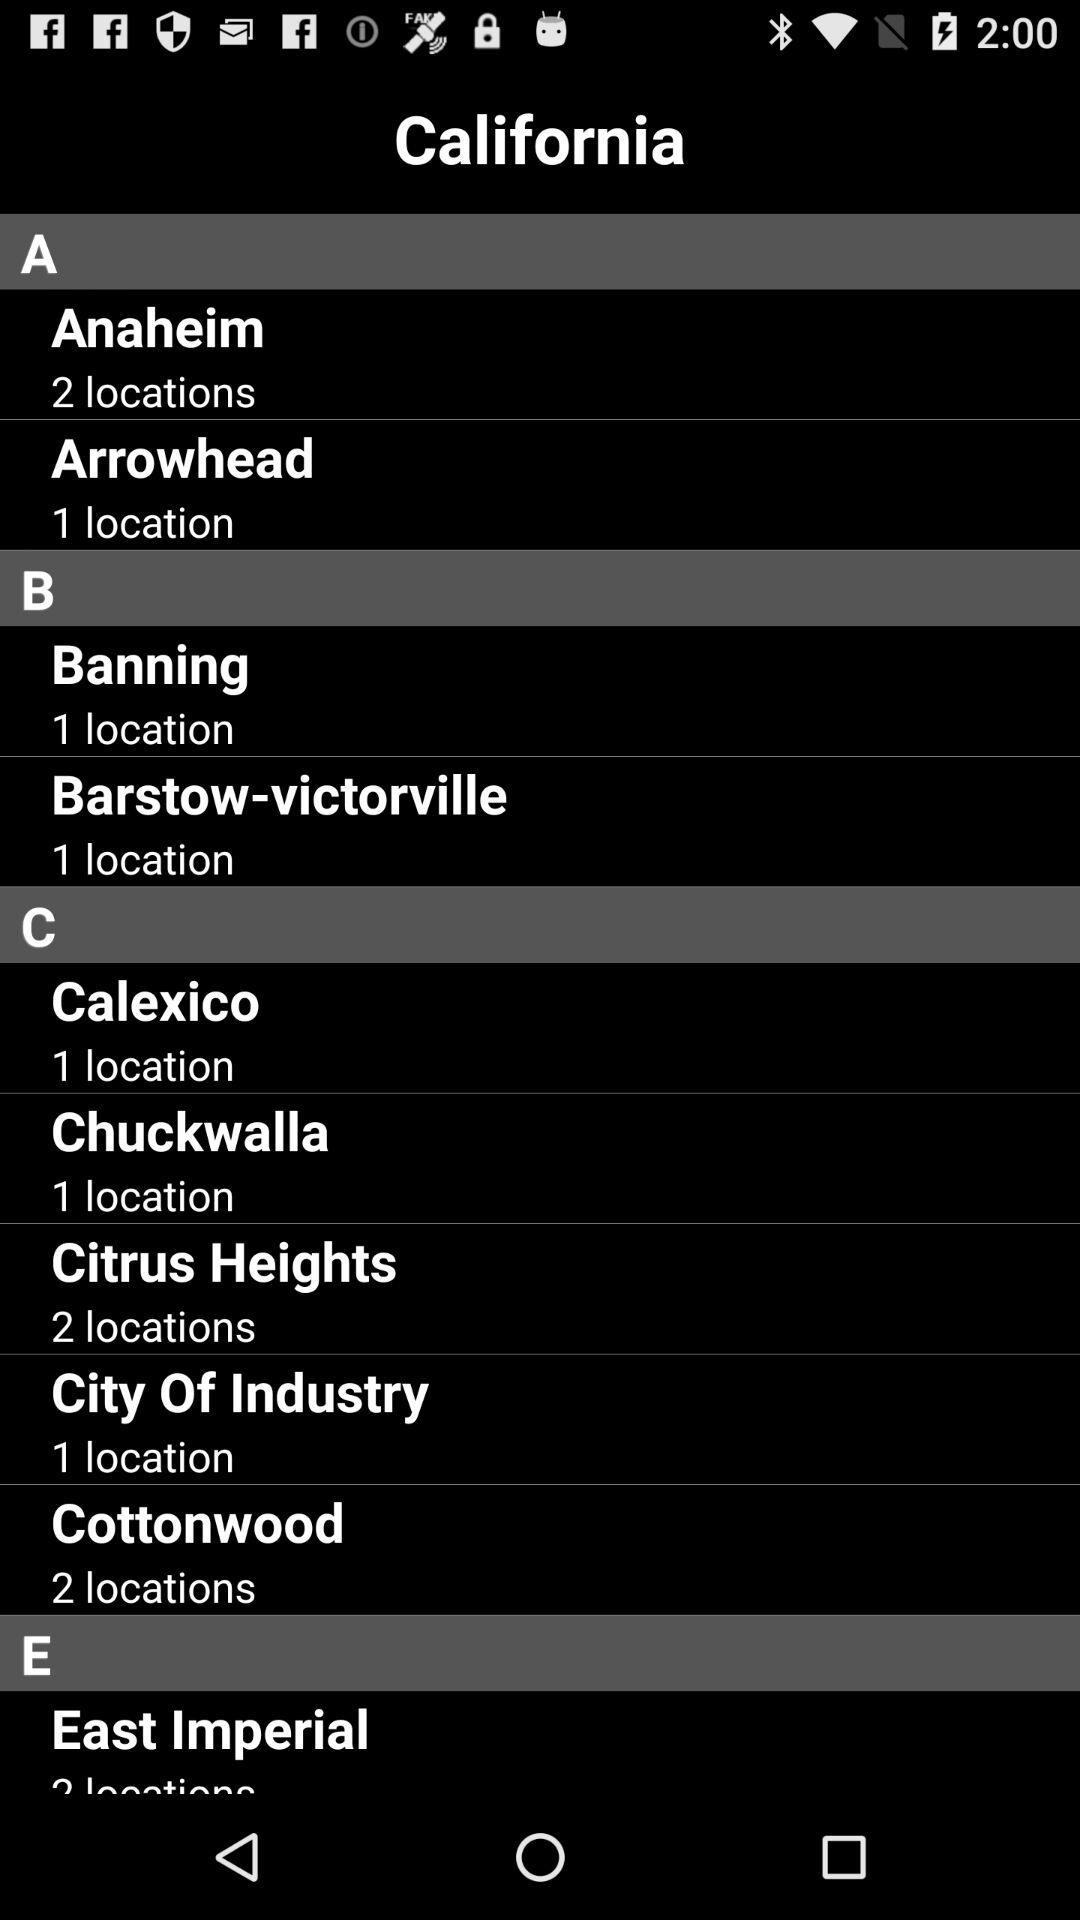What is the number of locations in Citrus Heights? The number of locations in Citrus Heights is 2. 